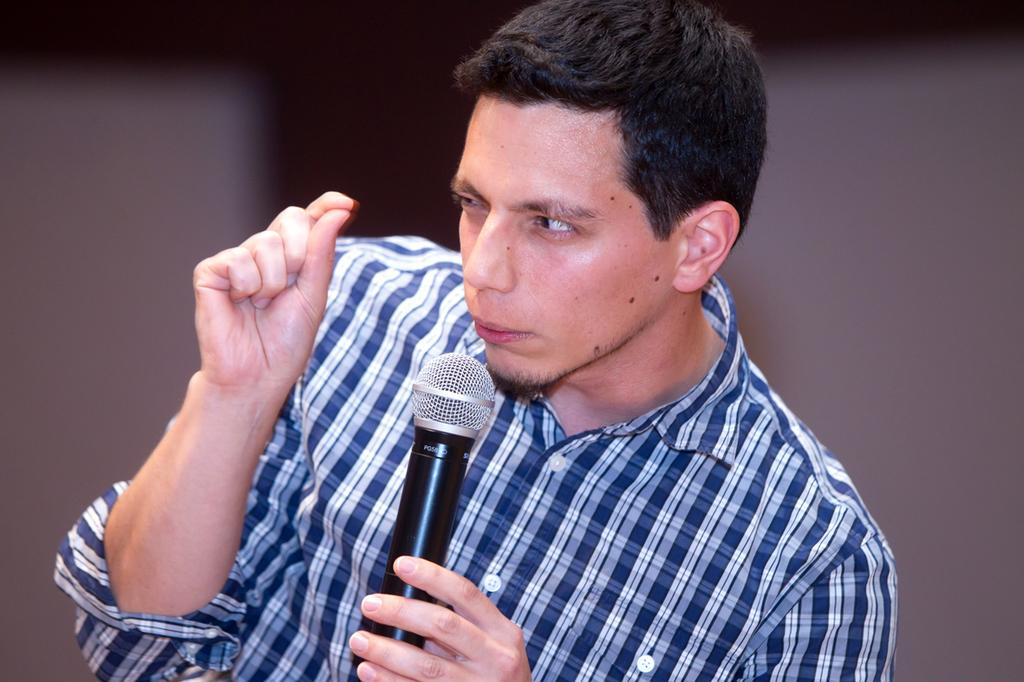Who is present in the image? There is a man in the image. What is the man holding in the image? The man is holding a microphone. What type of boats can be seen in the image? There are no boats present in the image. What kind of farm animals can be seen in the image? There are no farm animals present in the image. What type of building is visible in the image? There is no building visible in the image. 